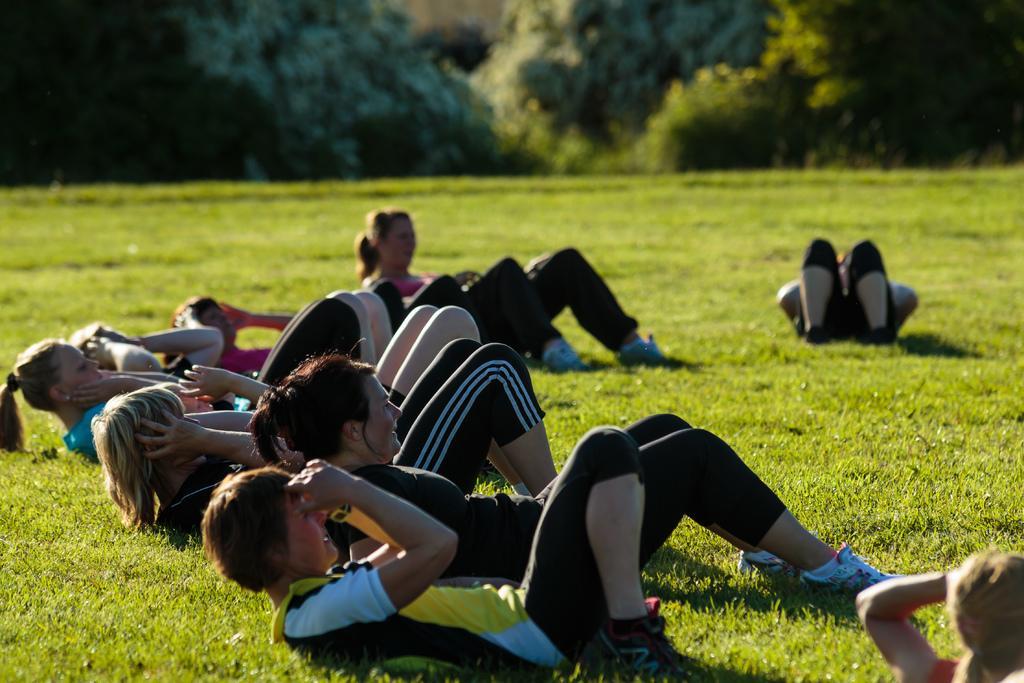Could you give a brief overview of what you see in this image? This picture is taken on the ground. On the ground there are people lying on it and performing the exercise. On the top there are trees. 